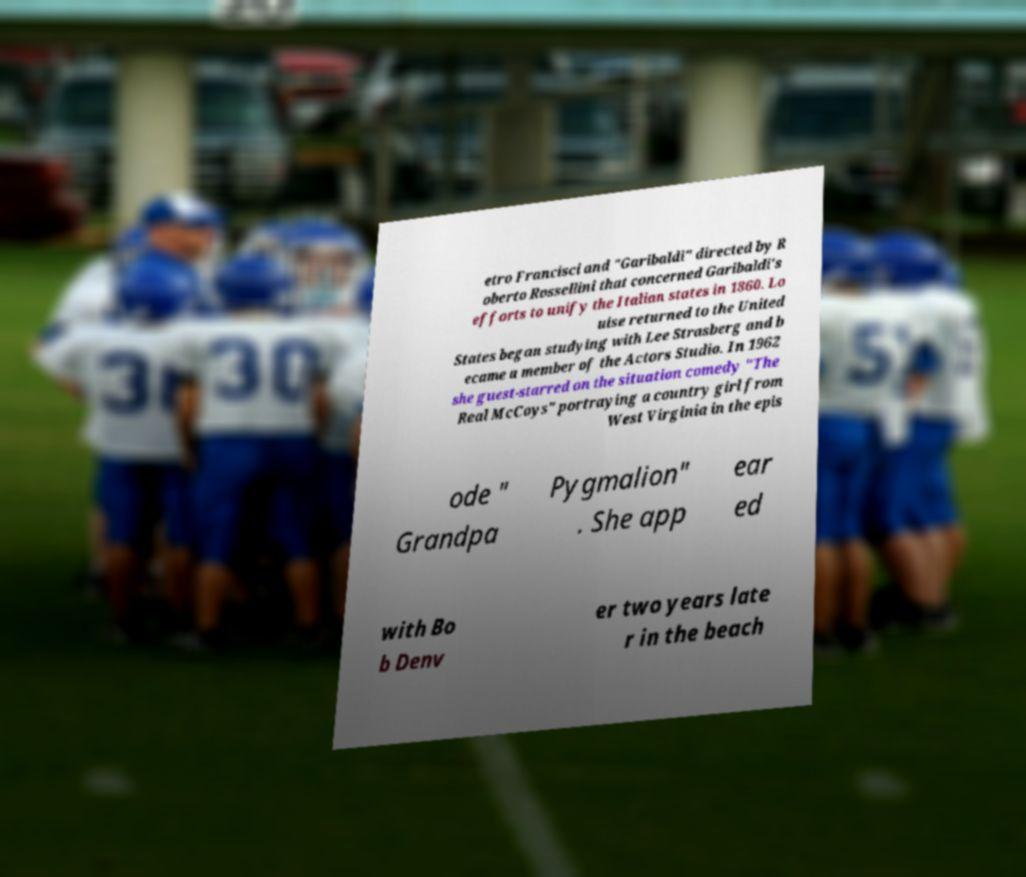Can you accurately transcribe the text from the provided image for me? etro Francisci and "Garibaldi" directed by R oberto Rossellini that concerned Garibaldi's efforts to unify the Italian states in 1860. Lo uise returned to the United States began studying with Lee Strasberg and b ecame a member of the Actors Studio. In 1962 she guest-starred on the situation comedy "The Real McCoys" portraying a country girl from West Virginia in the epis ode " Grandpa Pygmalion" . She app ear ed with Bo b Denv er two years late r in the beach 